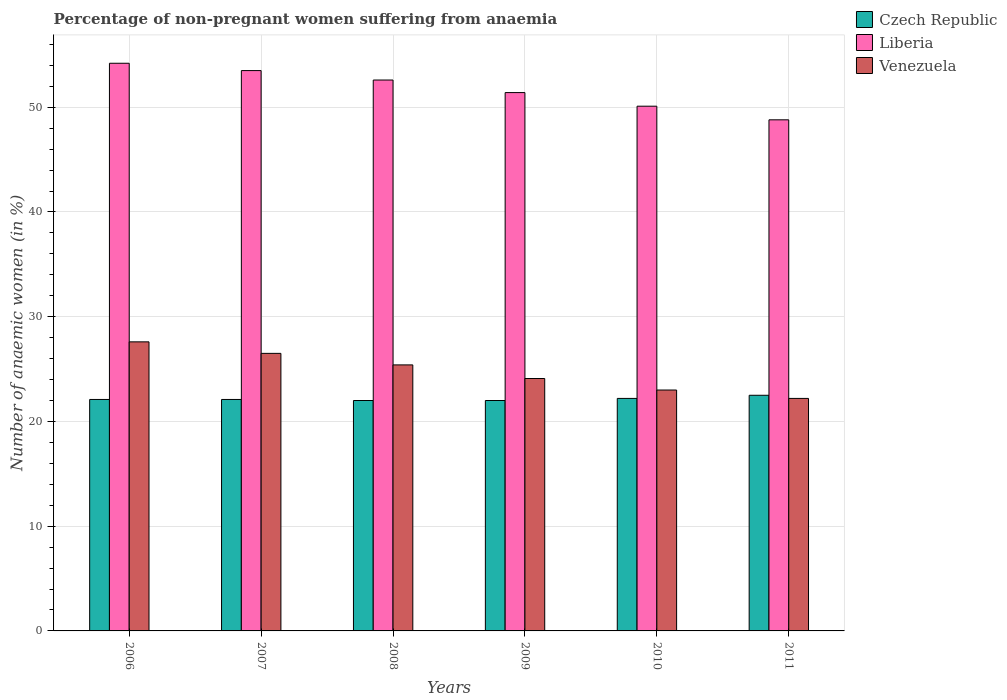How many groups of bars are there?
Offer a very short reply. 6. Are the number of bars on each tick of the X-axis equal?
Offer a very short reply. Yes. What is the percentage of non-pregnant women suffering from anaemia in Venezuela in 2010?
Your response must be concise. 23. Across all years, what is the maximum percentage of non-pregnant women suffering from anaemia in Venezuela?
Make the answer very short. 27.6. Across all years, what is the minimum percentage of non-pregnant women suffering from anaemia in Venezuela?
Ensure brevity in your answer.  22.2. In which year was the percentage of non-pregnant women suffering from anaemia in Venezuela maximum?
Give a very brief answer. 2006. In which year was the percentage of non-pregnant women suffering from anaemia in Liberia minimum?
Keep it short and to the point. 2011. What is the total percentage of non-pregnant women suffering from anaemia in Liberia in the graph?
Offer a very short reply. 310.6. What is the difference between the percentage of non-pregnant women suffering from anaemia in Czech Republic in 2008 and that in 2010?
Provide a short and direct response. -0.2. What is the difference between the percentage of non-pregnant women suffering from anaemia in Liberia in 2011 and the percentage of non-pregnant women suffering from anaemia in Venezuela in 2006?
Provide a short and direct response. 21.2. What is the average percentage of non-pregnant women suffering from anaemia in Liberia per year?
Your answer should be very brief. 51.77. In the year 2007, what is the difference between the percentage of non-pregnant women suffering from anaemia in Czech Republic and percentage of non-pregnant women suffering from anaemia in Venezuela?
Make the answer very short. -4.4. What is the ratio of the percentage of non-pregnant women suffering from anaemia in Venezuela in 2009 to that in 2010?
Ensure brevity in your answer.  1.05. What is the difference between the highest and the second highest percentage of non-pregnant women suffering from anaemia in Venezuela?
Make the answer very short. 1.1. What is the difference between the highest and the lowest percentage of non-pregnant women suffering from anaemia in Czech Republic?
Your answer should be very brief. 0.5. In how many years, is the percentage of non-pregnant women suffering from anaemia in Czech Republic greater than the average percentage of non-pregnant women suffering from anaemia in Czech Republic taken over all years?
Your answer should be very brief. 2. What does the 2nd bar from the left in 2010 represents?
Make the answer very short. Liberia. What does the 1st bar from the right in 2008 represents?
Ensure brevity in your answer.  Venezuela. Is it the case that in every year, the sum of the percentage of non-pregnant women suffering from anaemia in Czech Republic and percentage of non-pregnant women suffering from anaemia in Venezuela is greater than the percentage of non-pregnant women suffering from anaemia in Liberia?
Ensure brevity in your answer.  No. Does the graph contain any zero values?
Provide a short and direct response. No. What is the title of the graph?
Your answer should be very brief. Percentage of non-pregnant women suffering from anaemia. Does "Barbados" appear as one of the legend labels in the graph?
Offer a very short reply. No. What is the label or title of the Y-axis?
Provide a short and direct response. Number of anaemic women (in %). What is the Number of anaemic women (in %) in Czech Republic in 2006?
Provide a short and direct response. 22.1. What is the Number of anaemic women (in %) in Liberia in 2006?
Ensure brevity in your answer.  54.2. What is the Number of anaemic women (in %) in Venezuela in 2006?
Provide a short and direct response. 27.6. What is the Number of anaemic women (in %) in Czech Republic in 2007?
Your answer should be very brief. 22.1. What is the Number of anaemic women (in %) of Liberia in 2007?
Your response must be concise. 53.5. What is the Number of anaemic women (in %) of Venezuela in 2007?
Offer a very short reply. 26.5. What is the Number of anaemic women (in %) of Liberia in 2008?
Your response must be concise. 52.6. What is the Number of anaemic women (in %) of Venezuela in 2008?
Keep it short and to the point. 25.4. What is the Number of anaemic women (in %) in Czech Republic in 2009?
Provide a succinct answer. 22. What is the Number of anaemic women (in %) in Liberia in 2009?
Your answer should be very brief. 51.4. What is the Number of anaemic women (in %) of Venezuela in 2009?
Provide a short and direct response. 24.1. What is the Number of anaemic women (in %) in Liberia in 2010?
Provide a short and direct response. 50.1. What is the Number of anaemic women (in %) of Venezuela in 2010?
Offer a terse response. 23. What is the Number of anaemic women (in %) in Czech Republic in 2011?
Ensure brevity in your answer.  22.5. What is the Number of anaemic women (in %) of Liberia in 2011?
Your response must be concise. 48.8. What is the Number of anaemic women (in %) of Venezuela in 2011?
Offer a terse response. 22.2. Across all years, what is the maximum Number of anaemic women (in %) in Czech Republic?
Your response must be concise. 22.5. Across all years, what is the maximum Number of anaemic women (in %) of Liberia?
Ensure brevity in your answer.  54.2. Across all years, what is the maximum Number of anaemic women (in %) in Venezuela?
Offer a terse response. 27.6. Across all years, what is the minimum Number of anaemic women (in %) of Czech Republic?
Provide a short and direct response. 22. Across all years, what is the minimum Number of anaemic women (in %) of Liberia?
Keep it short and to the point. 48.8. Across all years, what is the minimum Number of anaemic women (in %) in Venezuela?
Provide a succinct answer. 22.2. What is the total Number of anaemic women (in %) of Czech Republic in the graph?
Give a very brief answer. 132.9. What is the total Number of anaemic women (in %) in Liberia in the graph?
Your response must be concise. 310.6. What is the total Number of anaemic women (in %) of Venezuela in the graph?
Offer a terse response. 148.8. What is the difference between the Number of anaemic women (in %) of Venezuela in 2006 and that in 2007?
Your answer should be compact. 1.1. What is the difference between the Number of anaemic women (in %) of Czech Republic in 2006 and that in 2008?
Your answer should be compact. 0.1. What is the difference between the Number of anaemic women (in %) of Liberia in 2006 and that in 2009?
Give a very brief answer. 2.8. What is the difference between the Number of anaemic women (in %) of Venezuela in 2006 and that in 2009?
Ensure brevity in your answer.  3.5. What is the difference between the Number of anaemic women (in %) of Liberia in 2006 and that in 2010?
Provide a succinct answer. 4.1. What is the difference between the Number of anaemic women (in %) in Venezuela in 2006 and that in 2010?
Keep it short and to the point. 4.6. What is the difference between the Number of anaemic women (in %) of Liberia in 2006 and that in 2011?
Offer a terse response. 5.4. What is the difference between the Number of anaemic women (in %) of Venezuela in 2006 and that in 2011?
Keep it short and to the point. 5.4. What is the difference between the Number of anaemic women (in %) in Czech Republic in 2007 and that in 2009?
Your response must be concise. 0.1. What is the difference between the Number of anaemic women (in %) in Liberia in 2007 and that in 2010?
Provide a short and direct response. 3.4. What is the difference between the Number of anaemic women (in %) of Czech Republic in 2007 and that in 2011?
Provide a succinct answer. -0.4. What is the difference between the Number of anaemic women (in %) in Liberia in 2007 and that in 2011?
Make the answer very short. 4.7. What is the difference between the Number of anaemic women (in %) in Czech Republic in 2008 and that in 2009?
Give a very brief answer. 0. What is the difference between the Number of anaemic women (in %) of Venezuela in 2008 and that in 2009?
Your answer should be compact. 1.3. What is the difference between the Number of anaemic women (in %) of Venezuela in 2008 and that in 2010?
Give a very brief answer. 2.4. What is the difference between the Number of anaemic women (in %) of Liberia in 2008 and that in 2011?
Offer a very short reply. 3.8. What is the difference between the Number of anaemic women (in %) of Liberia in 2009 and that in 2010?
Provide a short and direct response. 1.3. What is the difference between the Number of anaemic women (in %) in Venezuela in 2009 and that in 2010?
Offer a very short reply. 1.1. What is the difference between the Number of anaemic women (in %) of Czech Republic in 2009 and that in 2011?
Offer a terse response. -0.5. What is the difference between the Number of anaemic women (in %) of Venezuela in 2009 and that in 2011?
Provide a succinct answer. 1.9. What is the difference between the Number of anaemic women (in %) of Czech Republic in 2010 and that in 2011?
Your answer should be very brief. -0.3. What is the difference between the Number of anaemic women (in %) in Liberia in 2010 and that in 2011?
Ensure brevity in your answer.  1.3. What is the difference between the Number of anaemic women (in %) of Czech Republic in 2006 and the Number of anaemic women (in %) of Liberia in 2007?
Your answer should be very brief. -31.4. What is the difference between the Number of anaemic women (in %) in Liberia in 2006 and the Number of anaemic women (in %) in Venezuela in 2007?
Your answer should be compact. 27.7. What is the difference between the Number of anaemic women (in %) in Czech Republic in 2006 and the Number of anaemic women (in %) in Liberia in 2008?
Your answer should be very brief. -30.5. What is the difference between the Number of anaemic women (in %) in Czech Republic in 2006 and the Number of anaemic women (in %) in Venezuela in 2008?
Offer a very short reply. -3.3. What is the difference between the Number of anaemic women (in %) of Liberia in 2006 and the Number of anaemic women (in %) of Venezuela in 2008?
Offer a terse response. 28.8. What is the difference between the Number of anaemic women (in %) in Czech Republic in 2006 and the Number of anaemic women (in %) in Liberia in 2009?
Your response must be concise. -29.3. What is the difference between the Number of anaemic women (in %) in Liberia in 2006 and the Number of anaemic women (in %) in Venezuela in 2009?
Provide a short and direct response. 30.1. What is the difference between the Number of anaemic women (in %) in Czech Republic in 2006 and the Number of anaemic women (in %) in Liberia in 2010?
Your answer should be very brief. -28. What is the difference between the Number of anaemic women (in %) in Liberia in 2006 and the Number of anaemic women (in %) in Venezuela in 2010?
Provide a short and direct response. 31.2. What is the difference between the Number of anaemic women (in %) in Czech Republic in 2006 and the Number of anaemic women (in %) in Liberia in 2011?
Provide a succinct answer. -26.7. What is the difference between the Number of anaemic women (in %) in Czech Republic in 2007 and the Number of anaemic women (in %) in Liberia in 2008?
Provide a succinct answer. -30.5. What is the difference between the Number of anaemic women (in %) in Liberia in 2007 and the Number of anaemic women (in %) in Venezuela in 2008?
Make the answer very short. 28.1. What is the difference between the Number of anaemic women (in %) of Czech Republic in 2007 and the Number of anaemic women (in %) of Liberia in 2009?
Provide a short and direct response. -29.3. What is the difference between the Number of anaemic women (in %) in Liberia in 2007 and the Number of anaemic women (in %) in Venezuela in 2009?
Keep it short and to the point. 29.4. What is the difference between the Number of anaemic women (in %) in Czech Republic in 2007 and the Number of anaemic women (in %) in Venezuela in 2010?
Your response must be concise. -0.9. What is the difference between the Number of anaemic women (in %) of Liberia in 2007 and the Number of anaemic women (in %) of Venezuela in 2010?
Your response must be concise. 30.5. What is the difference between the Number of anaemic women (in %) of Czech Republic in 2007 and the Number of anaemic women (in %) of Liberia in 2011?
Your response must be concise. -26.7. What is the difference between the Number of anaemic women (in %) of Czech Republic in 2007 and the Number of anaemic women (in %) of Venezuela in 2011?
Offer a terse response. -0.1. What is the difference between the Number of anaemic women (in %) of Liberia in 2007 and the Number of anaemic women (in %) of Venezuela in 2011?
Your response must be concise. 31.3. What is the difference between the Number of anaemic women (in %) in Czech Republic in 2008 and the Number of anaemic women (in %) in Liberia in 2009?
Your answer should be very brief. -29.4. What is the difference between the Number of anaemic women (in %) of Czech Republic in 2008 and the Number of anaemic women (in %) of Venezuela in 2009?
Give a very brief answer. -2.1. What is the difference between the Number of anaemic women (in %) of Czech Republic in 2008 and the Number of anaemic women (in %) of Liberia in 2010?
Give a very brief answer. -28.1. What is the difference between the Number of anaemic women (in %) of Liberia in 2008 and the Number of anaemic women (in %) of Venezuela in 2010?
Your answer should be compact. 29.6. What is the difference between the Number of anaemic women (in %) of Czech Republic in 2008 and the Number of anaemic women (in %) of Liberia in 2011?
Provide a succinct answer. -26.8. What is the difference between the Number of anaemic women (in %) in Liberia in 2008 and the Number of anaemic women (in %) in Venezuela in 2011?
Your answer should be very brief. 30.4. What is the difference between the Number of anaemic women (in %) of Czech Republic in 2009 and the Number of anaemic women (in %) of Liberia in 2010?
Provide a succinct answer. -28.1. What is the difference between the Number of anaemic women (in %) of Liberia in 2009 and the Number of anaemic women (in %) of Venezuela in 2010?
Offer a very short reply. 28.4. What is the difference between the Number of anaemic women (in %) in Czech Republic in 2009 and the Number of anaemic women (in %) in Liberia in 2011?
Offer a terse response. -26.8. What is the difference between the Number of anaemic women (in %) in Liberia in 2009 and the Number of anaemic women (in %) in Venezuela in 2011?
Your answer should be compact. 29.2. What is the difference between the Number of anaemic women (in %) of Czech Republic in 2010 and the Number of anaemic women (in %) of Liberia in 2011?
Keep it short and to the point. -26.6. What is the difference between the Number of anaemic women (in %) in Czech Republic in 2010 and the Number of anaemic women (in %) in Venezuela in 2011?
Provide a short and direct response. 0. What is the difference between the Number of anaemic women (in %) of Liberia in 2010 and the Number of anaemic women (in %) of Venezuela in 2011?
Make the answer very short. 27.9. What is the average Number of anaemic women (in %) of Czech Republic per year?
Offer a terse response. 22.15. What is the average Number of anaemic women (in %) of Liberia per year?
Provide a short and direct response. 51.77. What is the average Number of anaemic women (in %) of Venezuela per year?
Your response must be concise. 24.8. In the year 2006, what is the difference between the Number of anaemic women (in %) in Czech Republic and Number of anaemic women (in %) in Liberia?
Provide a succinct answer. -32.1. In the year 2006, what is the difference between the Number of anaemic women (in %) of Liberia and Number of anaemic women (in %) of Venezuela?
Provide a short and direct response. 26.6. In the year 2007, what is the difference between the Number of anaemic women (in %) of Czech Republic and Number of anaemic women (in %) of Liberia?
Offer a terse response. -31.4. In the year 2007, what is the difference between the Number of anaemic women (in %) of Czech Republic and Number of anaemic women (in %) of Venezuela?
Your answer should be compact. -4.4. In the year 2007, what is the difference between the Number of anaemic women (in %) in Liberia and Number of anaemic women (in %) in Venezuela?
Your answer should be very brief. 27. In the year 2008, what is the difference between the Number of anaemic women (in %) of Czech Republic and Number of anaemic women (in %) of Liberia?
Your response must be concise. -30.6. In the year 2008, what is the difference between the Number of anaemic women (in %) in Liberia and Number of anaemic women (in %) in Venezuela?
Your response must be concise. 27.2. In the year 2009, what is the difference between the Number of anaemic women (in %) of Czech Republic and Number of anaemic women (in %) of Liberia?
Your answer should be compact. -29.4. In the year 2009, what is the difference between the Number of anaemic women (in %) in Liberia and Number of anaemic women (in %) in Venezuela?
Give a very brief answer. 27.3. In the year 2010, what is the difference between the Number of anaemic women (in %) in Czech Republic and Number of anaemic women (in %) in Liberia?
Make the answer very short. -27.9. In the year 2010, what is the difference between the Number of anaemic women (in %) of Liberia and Number of anaemic women (in %) of Venezuela?
Your answer should be compact. 27.1. In the year 2011, what is the difference between the Number of anaemic women (in %) in Czech Republic and Number of anaemic women (in %) in Liberia?
Provide a short and direct response. -26.3. In the year 2011, what is the difference between the Number of anaemic women (in %) in Liberia and Number of anaemic women (in %) in Venezuela?
Your answer should be very brief. 26.6. What is the ratio of the Number of anaemic women (in %) in Czech Republic in 2006 to that in 2007?
Your response must be concise. 1. What is the ratio of the Number of anaemic women (in %) in Liberia in 2006 to that in 2007?
Your answer should be very brief. 1.01. What is the ratio of the Number of anaemic women (in %) in Venezuela in 2006 to that in 2007?
Give a very brief answer. 1.04. What is the ratio of the Number of anaemic women (in %) in Liberia in 2006 to that in 2008?
Provide a short and direct response. 1.03. What is the ratio of the Number of anaemic women (in %) in Venezuela in 2006 to that in 2008?
Provide a short and direct response. 1.09. What is the ratio of the Number of anaemic women (in %) of Czech Republic in 2006 to that in 2009?
Make the answer very short. 1. What is the ratio of the Number of anaemic women (in %) of Liberia in 2006 to that in 2009?
Provide a succinct answer. 1.05. What is the ratio of the Number of anaemic women (in %) of Venezuela in 2006 to that in 2009?
Offer a terse response. 1.15. What is the ratio of the Number of anaemic women (in %) in Liberia in 2006 to that in 2010?
Offer a terse response. 1.08. What is the ratio of the Number of anaemic women (in %) in Czech Republic in 2006 to that in 2011?
Give a very brief answer. 0.98. What is the ratio of the Number of anaemic women (in %) in Liberia in 2006 to that in 2011?
Make the answer very short. 1.11. What is the ratio of the Number of anaemic women (in %) of Venezuela in 2006 to that in 2011?
Provide a short and direct response. 1.24. What is the ratio of the Number of anaemic women (in %) in Czech Republic in 2007 to that in 2008?
Provide a succinct answer. 1. What is the ratio of the Number of anaemic women (in %) in Liberia in 2007 to that in 2008?
Offer a very short reply. 1.02. What is the ratio of the Number of anaemic women (in %) of Venezuela in 2007 to that in 2008?
Provide a short and direct response. 1.04. What is the ratio of the Number of anaemic women (in %) in Liberia in 2007 to that in 2009?
Your response must be concise. 1.04. What is the ratio of the Number of anaemic women (in %) in Venezuela in 2007 to that in 2009?
Give a very brief answer. 1.1. What is the ratio of the Number of anaemic women (in %) in Liberia in 2007 to that in 2010?
Your response must be concise. 1.07. What is the ratio of the Number of anaemic women (in %) in Venezuela in 2007 to that in 2010?
Keep it short and to the point. 1.15. What is the ratio of the Number of anaemic women (in %) in Czech Republic in 2007 to that in 2011?
Your answer should be very brief. 0.98. What is the ratio of the Number of anaemic women (in %) of Liberia in 2007 to that in 2011?
Ensure brevity in your answer.  1.1. What is the ratio of the Number of anaemic women (in %) in Venezuela in 2007 to that in 2011?
Provide a short and direct response. 1.19. What is the ratio of the Number of anaemic women (in %) of Liberia in 2008 to that in 2009?
Your answer should be very brief. 1.02. What is the ratio of the Number of anaemic women (in %) of Venezuela in 2008 to that in 2009?
Your answer should be very brief. 1.05. What is the ratio of the Number of anaemic women (in %) of Liberia in 2008 to that in 2010?
Provide a short and direct response. 1.05. What is the ratio of the Number of anaemic women (in %) in Venezuela in 2008 to that in 2010?
Give a very brief answer. 1.1. What is the ratio of the Number of anaemic women (in %) of Czech Republic in 2008 to that in 2011?
Your answer should be very brief. 0.98. What is the ratio of the Number of anaemic women (in %) in Liberia in 2008 to that in 2011?
Ensure brevity in your answer.  1.08. What is the ratio of the Number of anaemic women (in %) in Venezuela in 2008 to that in 2011?
Offer a terse response. 1.14. What is the ratio of the Number of anaemic women (in %) in Liberia in 2009 to that in 2010?
Make the answer very short. 1.03. What is the ratio of the Number of anaemic women (in %) in Venezuela in 2009 to that in 2010?
Ensure brevity in your answer.  1.05. What is the ratio of the Number of anaemic women (in %) in Czech Republic in 2009 to that in 2011?
Make the answer very short. 0.98. What is the ratio of the Number of anaemic women (in %) of Liberia in 2009 to that in 2011?
Provide a succinct answer. 1.05. What is the ratio of the Number of anaemic women (in %) of Venezuela in 2009 to that in 2011?
Ensure brevity in your answer.  1.09. What is the ratio of the Number of anaemic women (in %) in Czech Republic in 2010 to that in 2011?
Keep it short and to the point. 0.99. What is the ratio of the Number of anaemic women (in %) of Liberia in 2010 to that in 2011?
Your answer should be very brief. 1.03. What is the ratio of the Number of anaemic women (in %) in Venezuela in 2010 to that in 2011?
Your answer should be very brief. 1.04. What is the difference between the highest and the second highest Number of anaemic women (in %) in Liberia?
Ensure brevity in your answer.  0.7. What is the difference between the highest and the second highest Number of anaemic women (in %) of Venezuela?
Provide a short and direct response. 1.1. What is the difference between the highest and the lowest Number of anaemic women (in %) of Czech Republic?
Make the answer very short. 0.5. What is the difference between the highest and the lowest Number of anaemic women (in %) in Liberia?
Keep it short and to the point. 5.4. What is the difference between the highest and the lowest Number of anaemic women (in %) of Venezuela?
Provide a short and direct response. 5.4. 